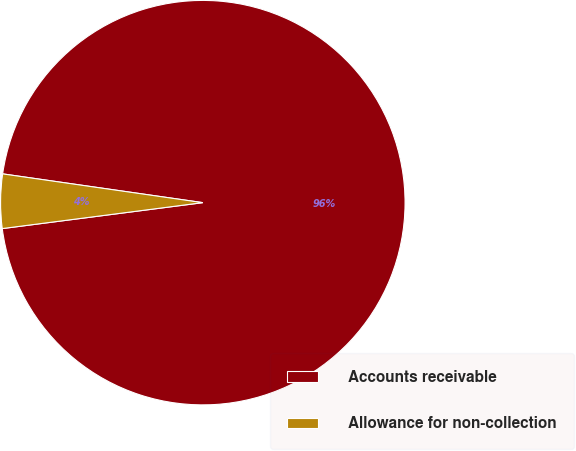<chart> <loc_0><loc_0><loc_500><loc_500><pie_chart><fcel>Accounts receivable<fcel>Allowance for non-collection<nl><fcel>95.68%<fcel>4.32%<nl></chart> 